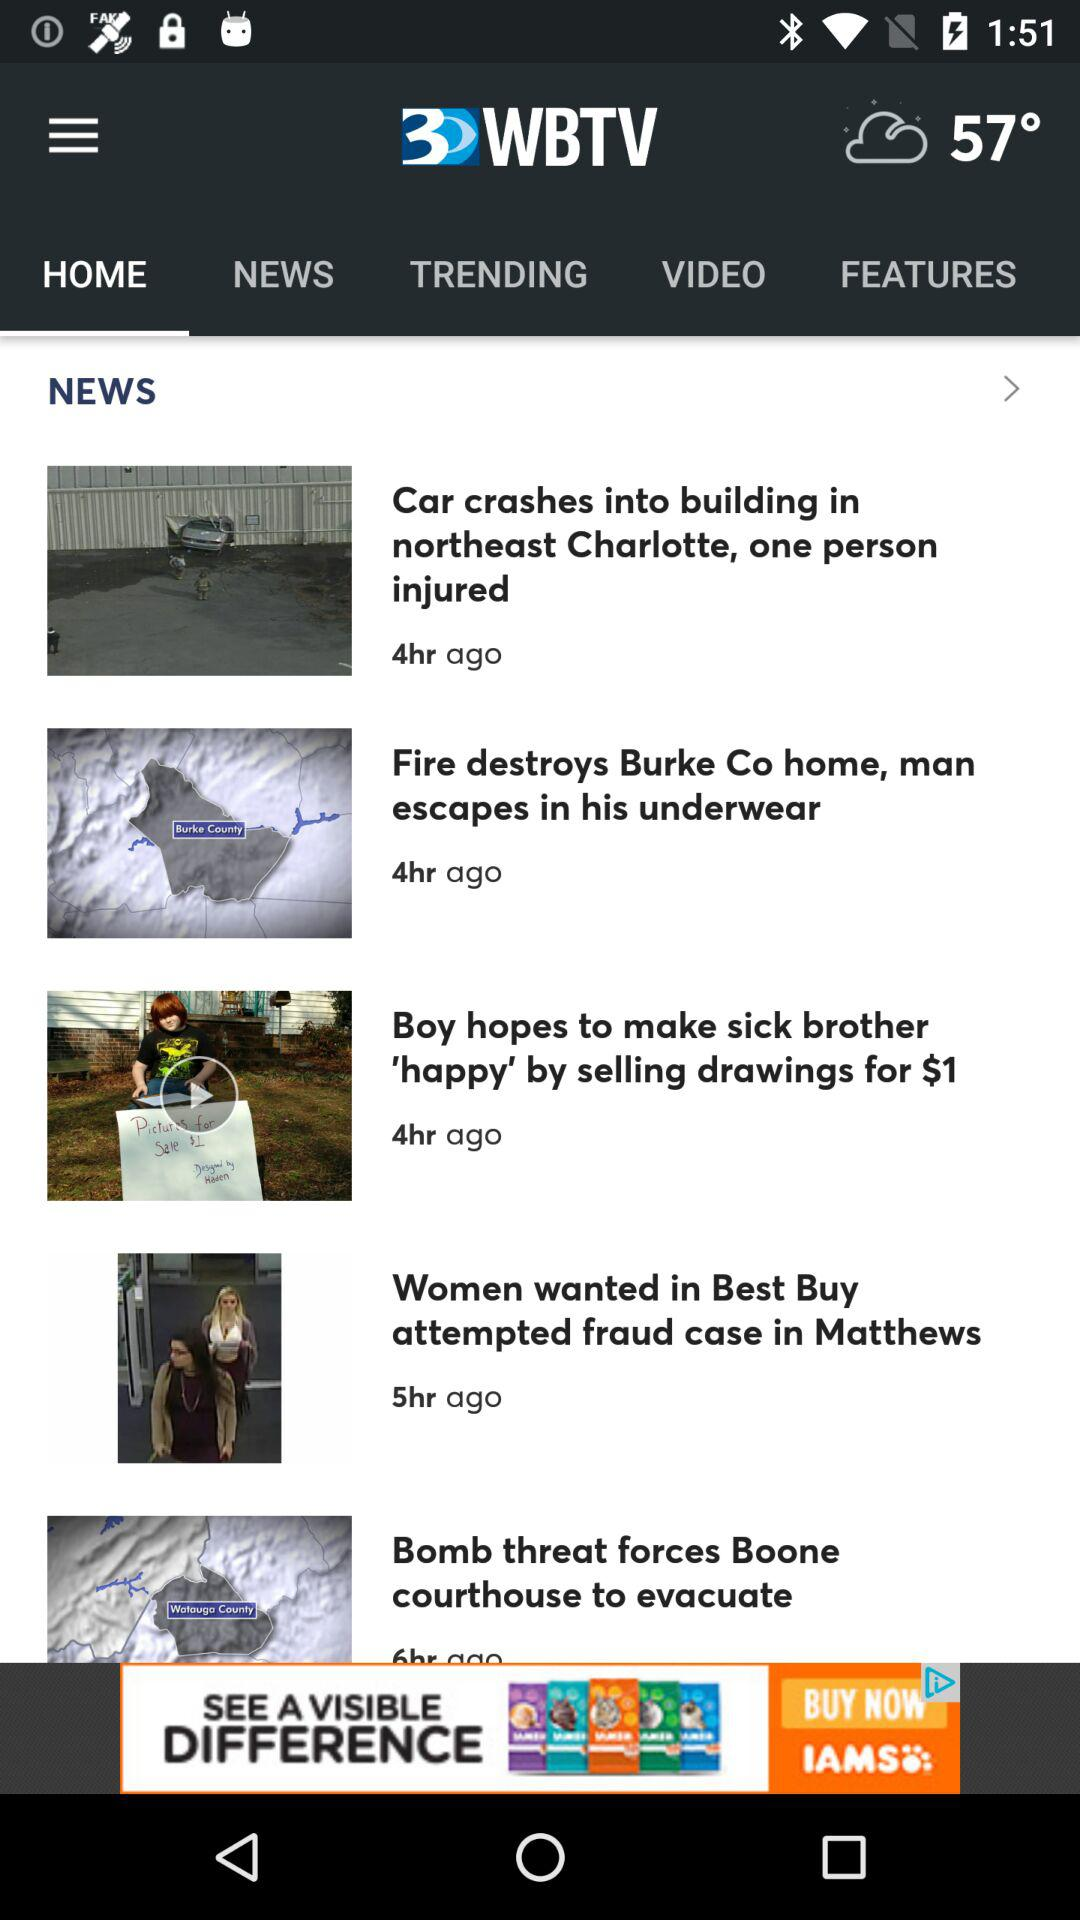How many hours ago was the news "Fire destroys Burke Co home, man escapes in his underwear" posted? The news "Fire destroys Burke Co home, man escapes in his underwear" was posted 4 hours ago. 